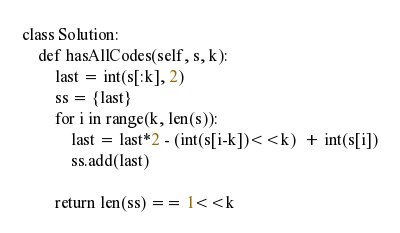Convert code to text. <code><loc_0><loc_0><loc_500><loc_500><_Python_>class Solution:
    def hasAllCodes(self, s, k):
        last = int(s[:k], 2)
        ss = {last}
        for i in range(k, len(s)):
            last = last*2 - (int(s[i-k])<<k)  + int(s[i])
            ss.add(last)
        
        return len(ss) == 1<<k
</code> 